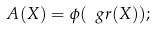<formula> <loc_0><loc_0><loc_500><loc_500>A ( X ) = \phi ( \ g r ( X ) ) ;</formula> 